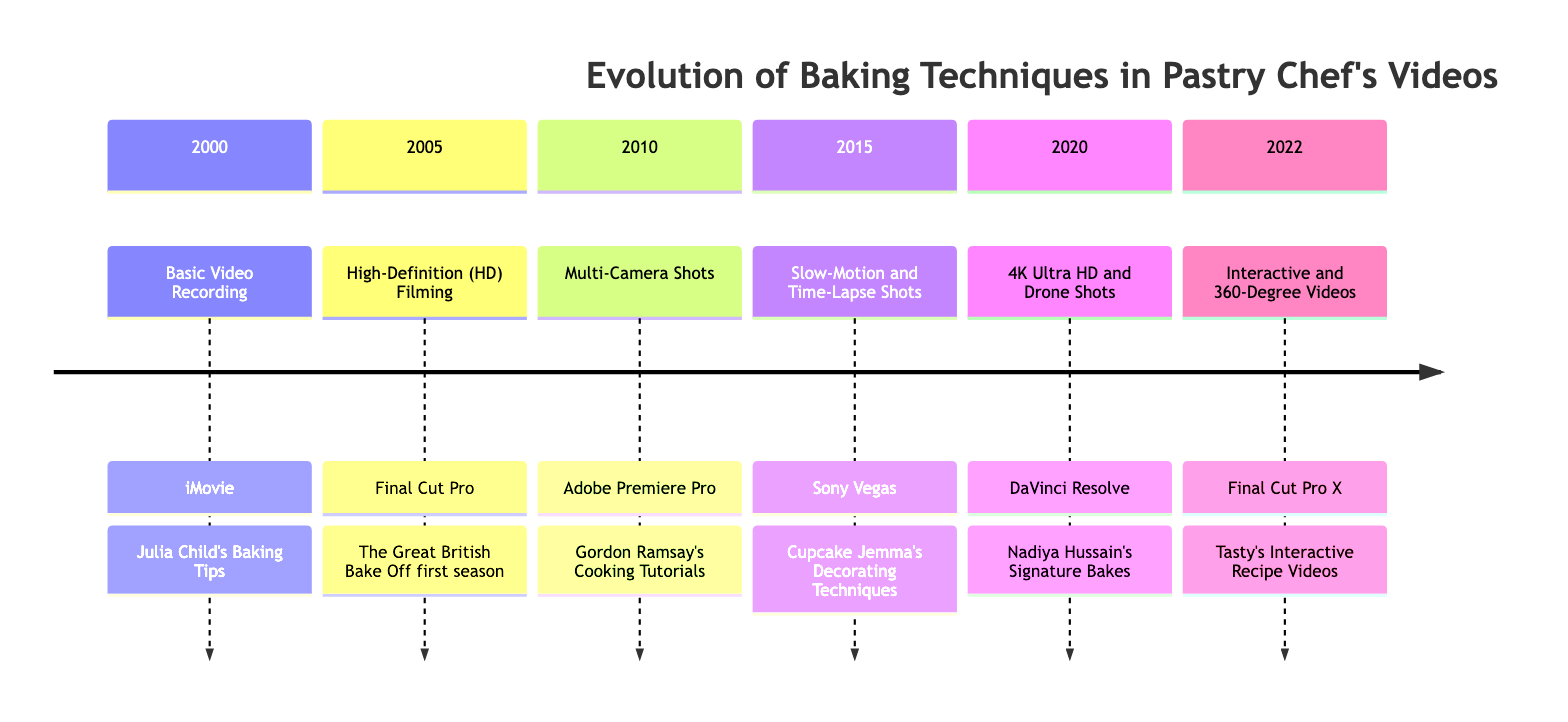What baking technique was introduced in 2005? The diagram states that in 2005, the technique introduced was High-Definition (HD) Filming.
Answer: High-Definition (HD) Filming Which video editor tool was used for the baking technique in 2010? According to the timeline, the video editor tool used in 2010 for Multi-Camera Shots was Adobe Premiere Pro.
Answer: Adobe Premiere Pro How many notable videos are listed for the year 2015? The timeline specifies that there is one notable video listed for the year 2015, which is Cupcake Jemma's Decorating Techniques.
Answer: 1 What is the latest technique mentioned in the timeline? The latest technique in the timeline is Interactive and 360-Degree Videos, which appears in the year 2022.
Answer: Interactive and 360-Degree Videos Which technique allows viewers to engage more deeply with the baking process? The timeline notes that Interactive and 360-Degree Videos allow viewers to engage more deeply with the baking process.
Answer: Interactive and 360-Degree Videos What was the focus of the remarkable videos listed in 2000? The remarkable video listed for 2000 is Julia Child's Baking Tips, which focuses on basic baking techniques using simple video recording.
Answer: Julia Child's Baking Tips What type of shots were incorporated in 2015 to emphasize intricate steps? In 2015, Slow-Motion and Time-Lapse Shots were incorporated to emphasize intricate and lengthy baking steps.
Answer: Slow-Motion and Time-Lapse Shots Which year marked the adoption of 4K Ultra HD and drone shots? The timeline indicates that the adoption of 4K Ultra HD and drone shots occurred in the year 2020.
Answer: 2020 What video editing tool was introduced with the technique in 2022? The video editing tool mentioned for the technique in 2022 (Interactive and 360-Degree Videos) is Final Cut Pro X.
Answer: Final Cut Pro X 